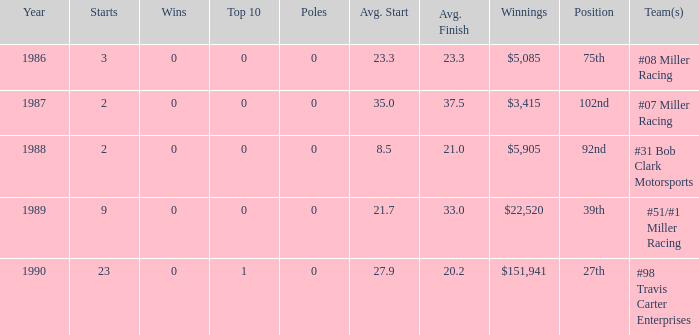Can you identify the racing team/s that held the 92nd spot? #31 Bob Clark Motorsports. 